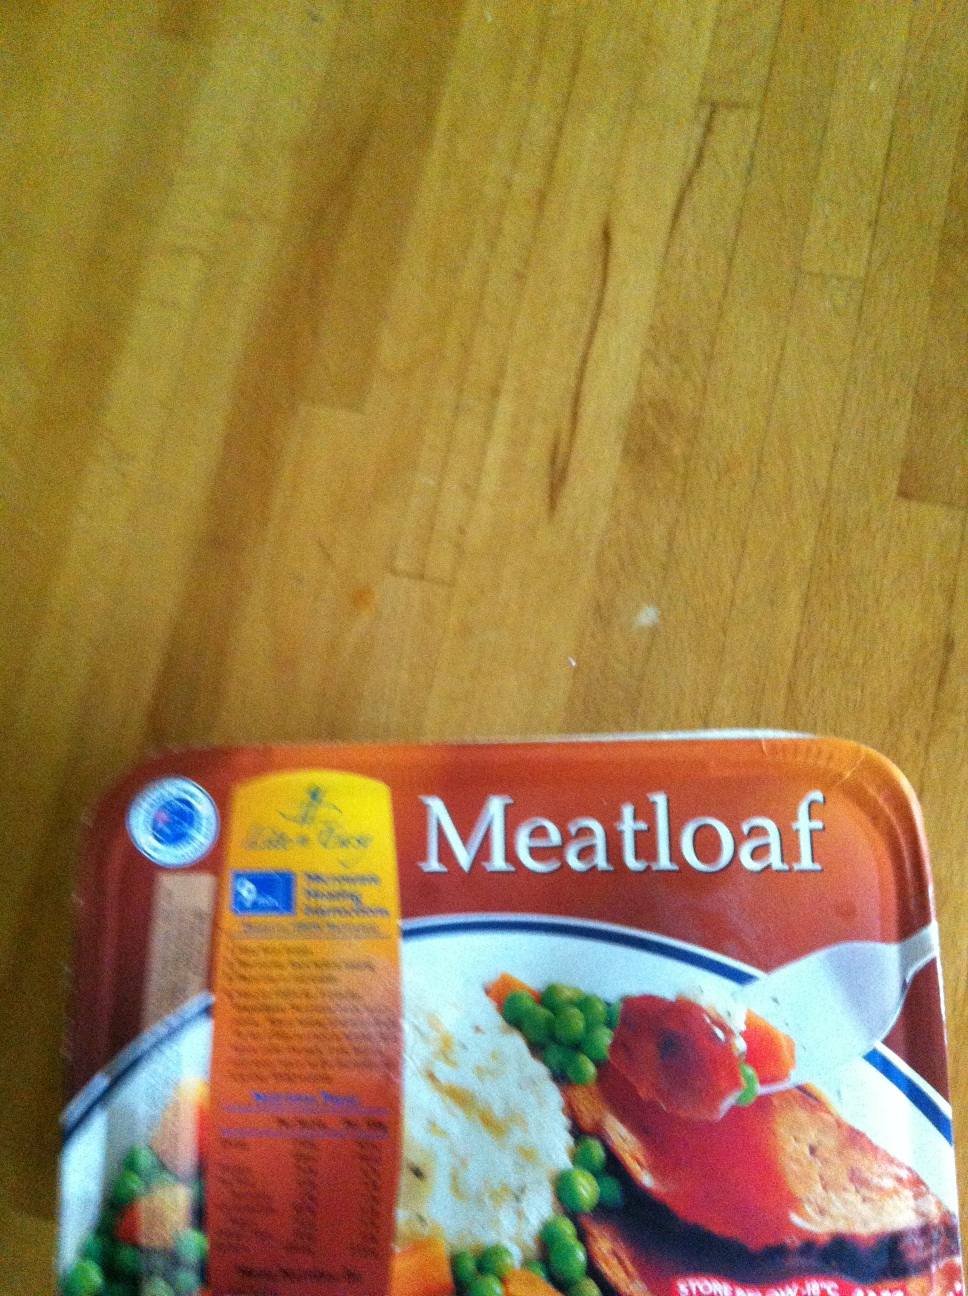How would you prepare this meatloaf for a meal? To prepare this meatloaf for a meal, first read the cooking instructions provided on the packaging. Generally, you would preheat your oven to a specified temperature, then remove the meatloaf from its packaging and place it in an oven-safe dish. Bake it in the oven for the recommended amount of time, usually around 45 minutes to 1 hour. If the instructions allow, you might also microwave it for a quicker meal - usually around 5-7 minutes depending on your microwave's power. Once heated thoroughly, serve it with the included vegetables or complement it with your favorite side dishes, such as mashed potatoes, gravy, or a fresh salad to create a complete meal. 